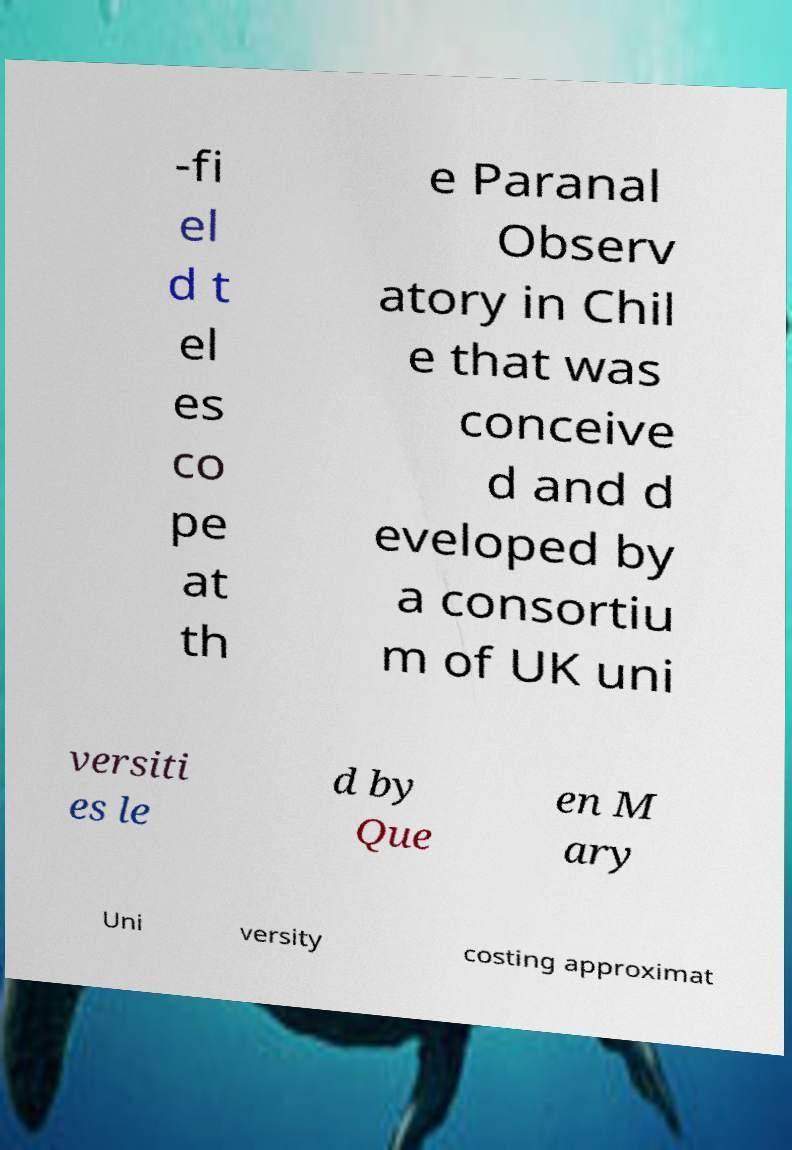For documentation purposes, I need the text within this image transcribed. Could you provide that? -fi el d t el es co pe at th e Paranal Observ atory in Chil e that was conceive d and d eveloped by a consortiu m of UK uni versiti es le d by Que en M ary Uni versity costing approximat 